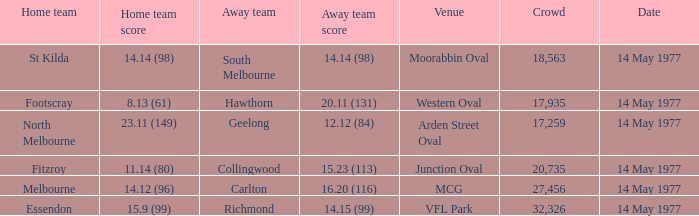What's the score of the home team against richmond's away team when the crowd exceeds 20,735? 15.9 (99). 